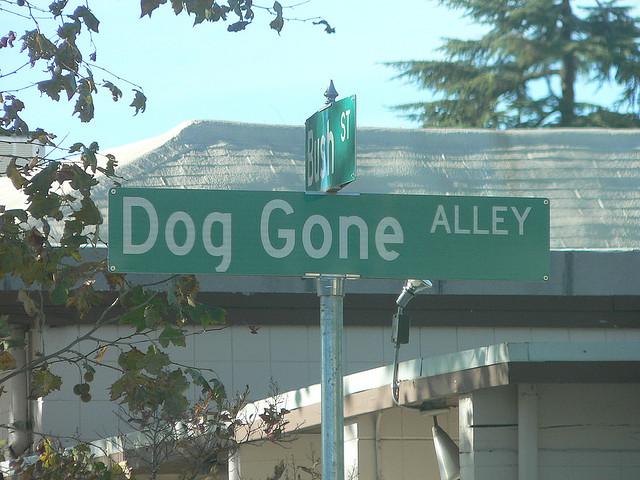What is the name of the street facing the photographer?
Be succinct. Dog gone alley. Is an animal referenced in this sign?
Be succinct. Yes. Is it winter?
Quick response, please. No. Are there any flower pots on the ground?
Concise answer only. No. 